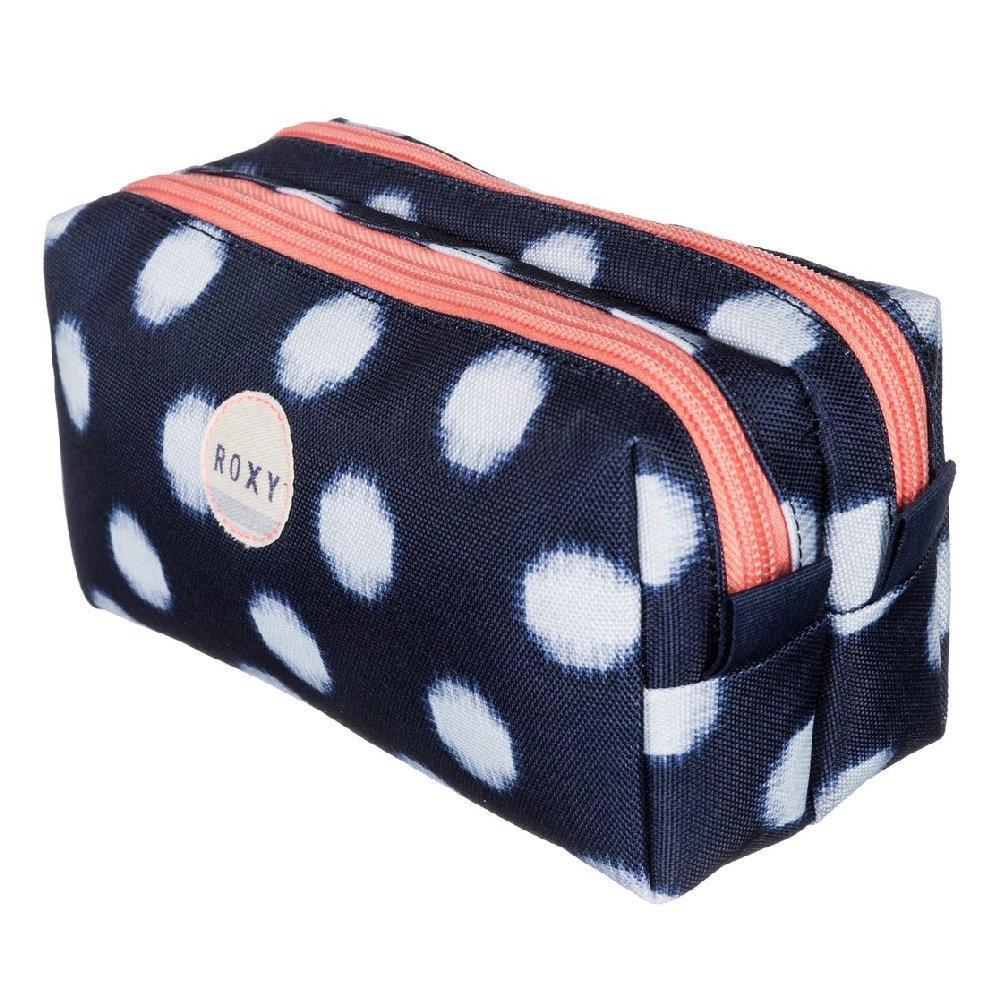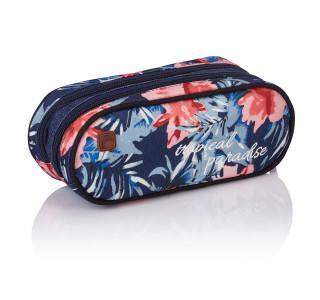The first image is the image on the left, the second image is the image on the right. Evaluate the accuracy of this statement regarding the images: "The pencil case in the right image is predominantly pink.". Is it true? Answer yes or no. No. The first image is the image on the left, the second image is the image on the right. Evaluate the accuracy of this statement regarding the images: "There are flowers on the case in the image on the left.". Is it true? Answer yes or no. No. 